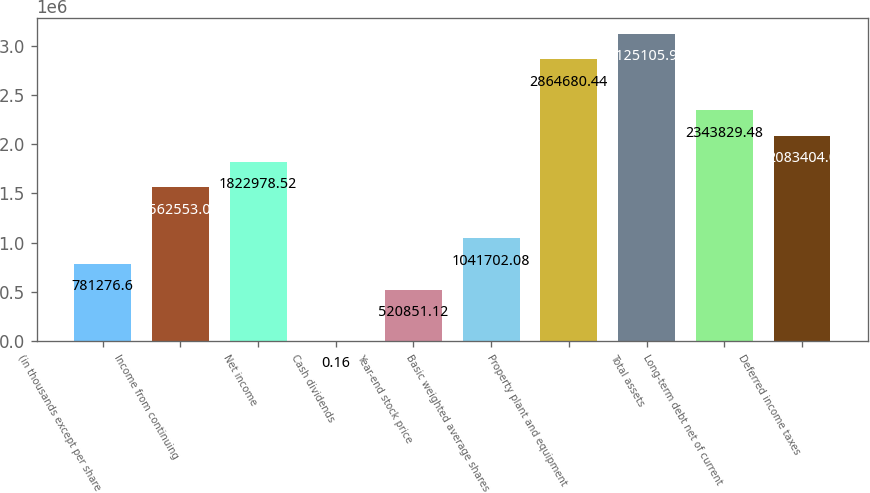Convert chart to OTSL. <chart><loc_0><loc_0><loc_500><loc_500><bar_chart><fcel>(in thousands except per share<fcel>Income from continuing<fcel>Net income<fcel>Cash dividends<fcel>Year-end stock price<fcel>Basic weighted average shares<fcel>Property plant and equipment<fcel>Total assets<fcel>Long-term debt net of current<fcel>Deferred income taxes<nl><fcel>781277<fcel>1.56255e+06<fcel>1.82298e+06<fcel>0.16<fcel>520851<fcel>1.0417e+06<fcel>2.86468e+06<fcel>3.12511e+06<fcel>2.34383e+06<fcel>2.0834e+06<nl></chart> 